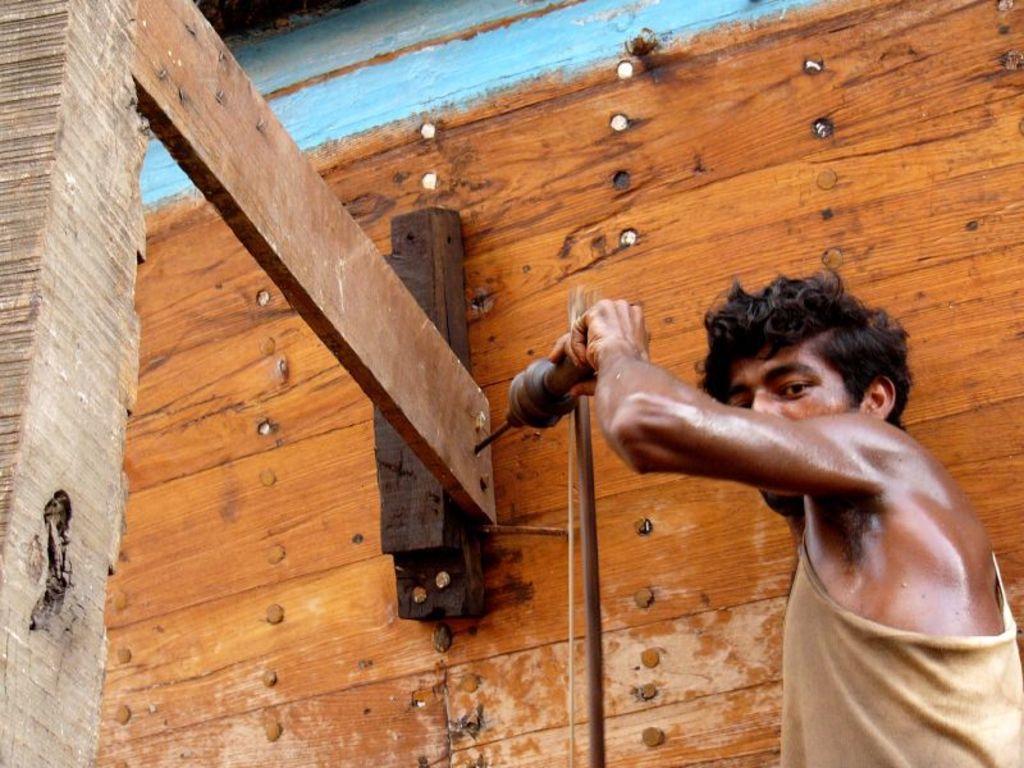Could you give a brief overview of what you see in this image? A person is standing on the right and holding a drilling machine. There is a piece of wood. There is a wooden background which has screws. 